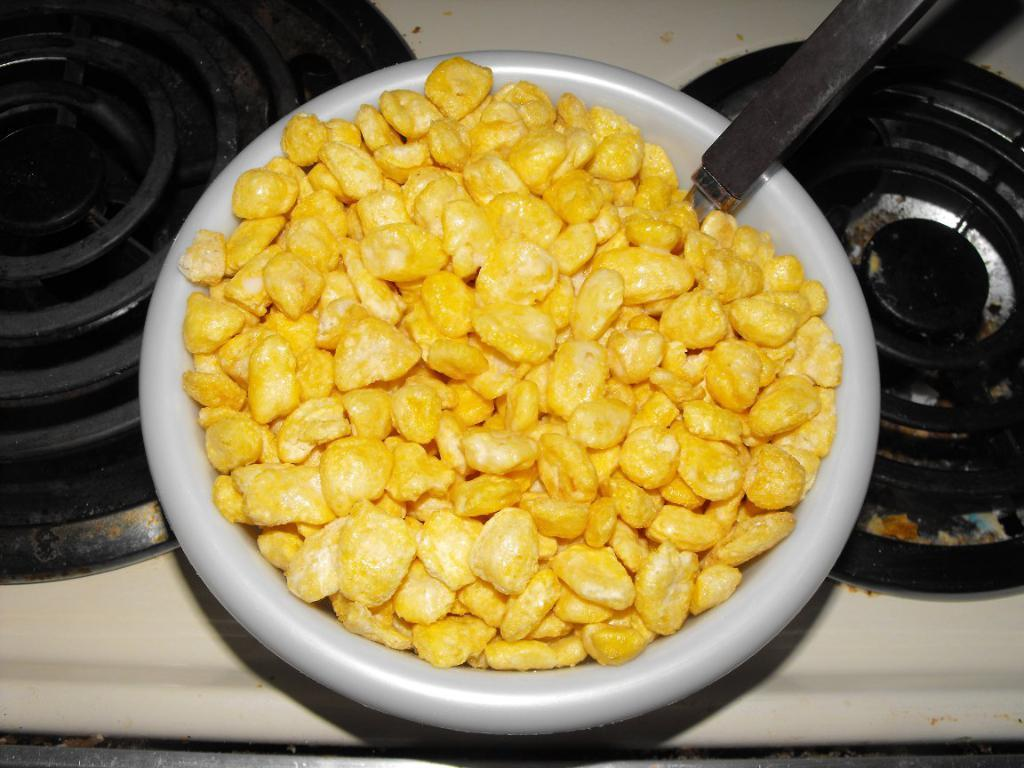What type of cooking appliances are visible in the image? There are stoves in the image. What utensil can be seen in the image? There is a spoon in the image. What is in the bowl that is visible in the image? There is a bowl with snacks in the image. Where might this image have been taken? The image is likely taken in a room, as there are stoves and a bowl with snacks present. Can you see any nests in the image? There are no nests present in the image. What type of milk is being used in the image? There is no milk present in the image. 